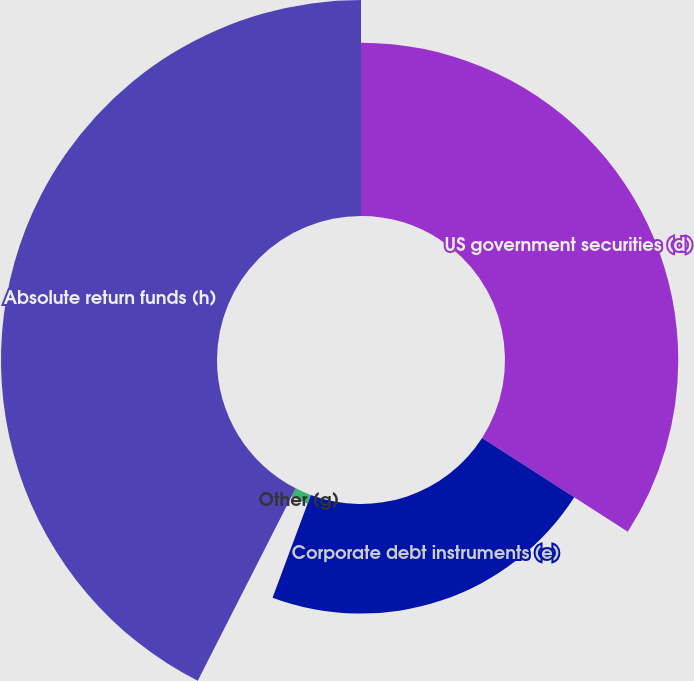Convert chart. <chart><loc_0><loc_0><loc_500><loc_500><pie_chart><fcel>US government securities (d)<fcel>Corporate debt instruments (e)<fcel>Other (g)<fcel>Absolute return funds (h)<nl><fcel>34.1%<fcel>21.57%<fcel>1.82%<fcel>42.51%<nl></chart> 